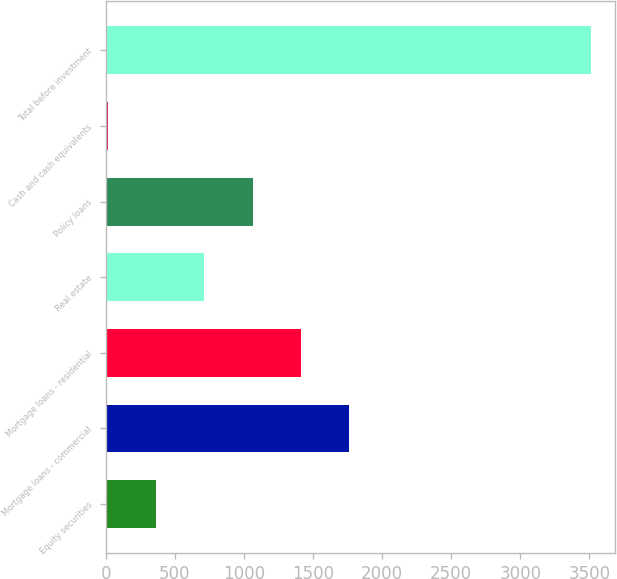Convert chart to OTSL. <chart><loc_0><loc_0><loc_500><loc_500><bar_chart><fcel>Equity securities<fcel>Mortgage loans - commercial<fcel>Mortgage loans - residential<fcel>Real estate<fcel>Policy loans<fcel>Cash and cash equivalents<fcel>Total before investment<nl><fcel>362.93<fcel>1762.65<fcel>1412.72<fcel>712.86<fcel>1062.79<fcel>13<fcel>3512.3<nl></chart> 